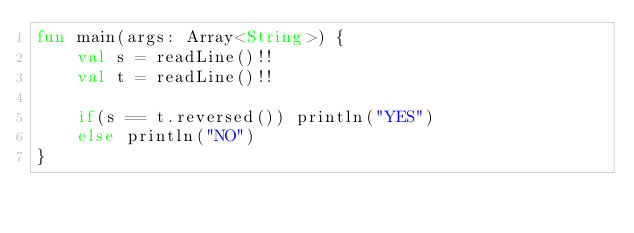Convert code to text. <code><loc_0><loc_0><loc_500><loc_500><_Kotlin_>fun main(args: Array<String>) {
    val s = readLine()!!
    val t = readLine()!!

    if(s == t.reversed()) println("YES")
    else println("NO")
}</code> 